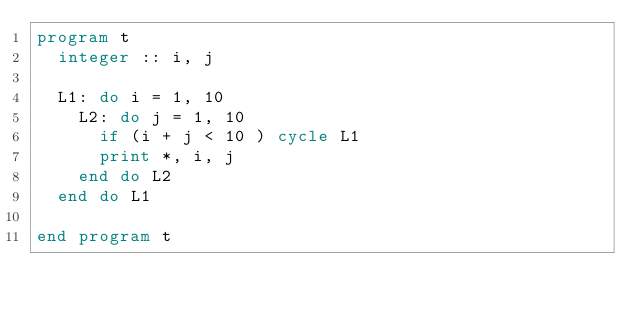Convert code to text. <code><loc_0><loc_0><loc_500><loc_500><_FORTRAN_>program t
  integer :: i, j

  L1: do i = 1, 10
    L2: do j = 1, 10 
      if (i + j < 10 ) cycle L1
      print *, i, j
    end do L2 
  end do L1

end program t
</code> 